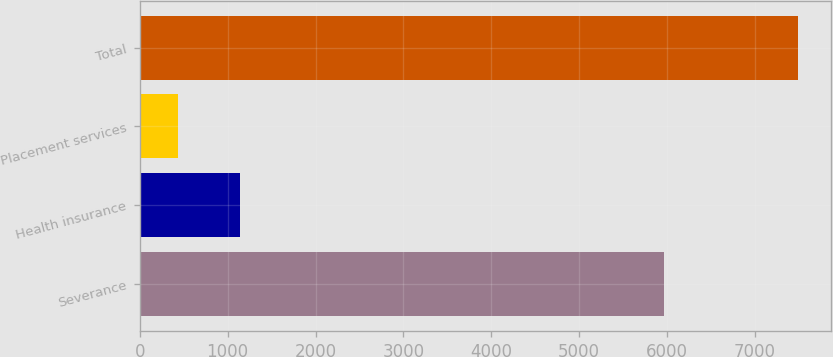<chart> <loc_0><loc_0><loc_500><loc_500><bar_chart><fcel>Severance<fcel>Health insurance<fcel>Placement services<fcel>Total<nl><fcel>5966<fcel>1136.8<fcel>431<fcel>7489<nl></chart> 